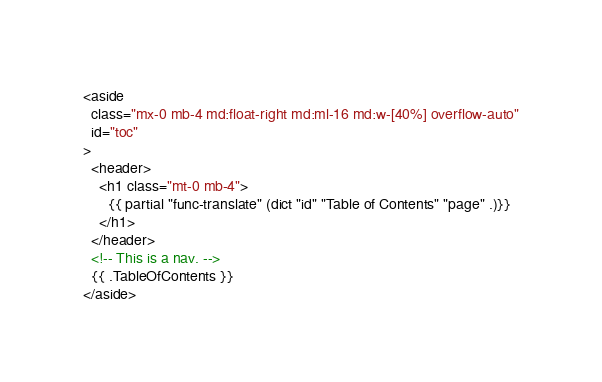<code> <loc_0><loc_0><loc_500><loc_500><_HTML_><aside
  class="mx-0 mb-4 md:float-right md:ml-16 md:w-[40%] overflow-auto"
  id="toc"
>
  <header>
    <h1 class="mt-0 mb-4">
      {{ partial "func-translate" (dict "id" "Table of Contents" "page" .)}}
    </h1>
  </header>
  <!-- This is a nav. -->
  {{ .TableOfContents }}
</aside>
</code> 